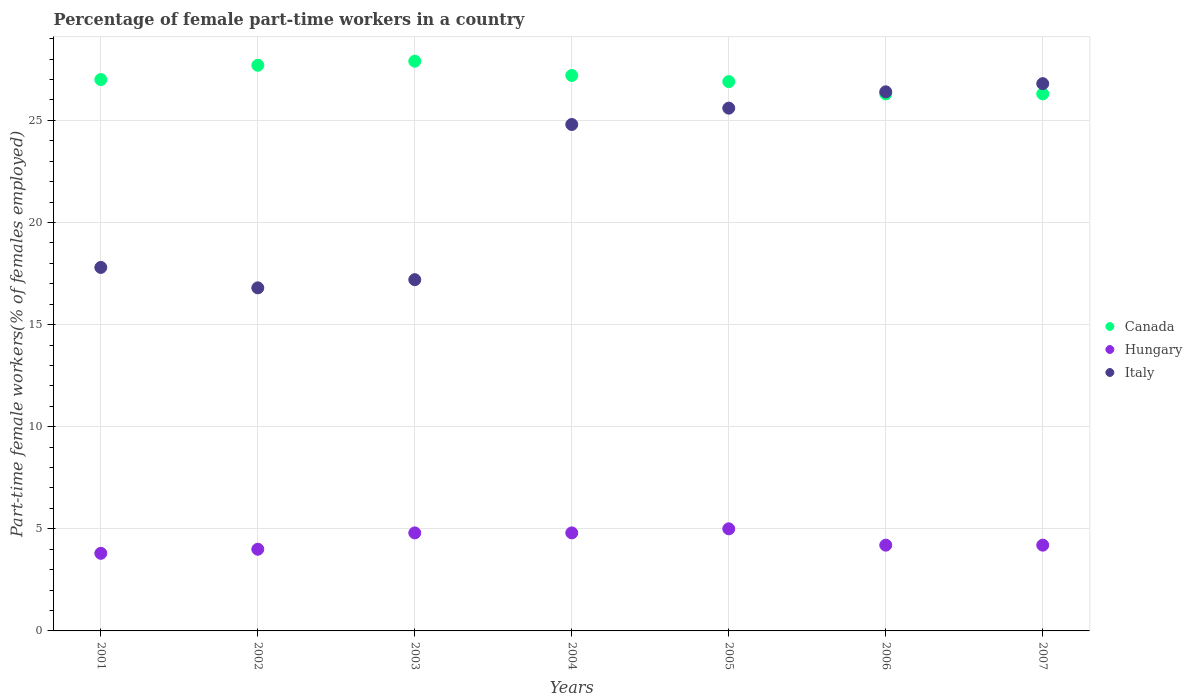Is the number of dotlines equal to the number of legend labels?
Your answer should be very brief. Yes. What is the percentage of female part-time workers in Hungary in 2007?
Ensure brevity in your answer.  4.2. Across all years, what is the minimum percentage of female part-time workers in Canada?
Your response must be concise. 26.3. In which year was the percentage of female part-time workers in Italy maximum?
Offer a very short reply. 2007. In which year was the percentage of female part-time workers in Canada minimum?
Offer a very short reply. 2006. What is the total percentage of female part-time workers in Italy in the graph?
Provide a short and direct response. 155.4. What is the difference between the percentage of female part-time workers in Hungary in 2002 and that in 2007?
Your response must be concise. -0.2. What is the difference between the percentage of female part-time workers in Hungary in 2004 and the percentage of female part-time workers in Italy in 2002?
Give a very brief answer. -12. What is the average percentage of female part-time workers in Hungary per year?
Provide a succinct answer. 4.4. In the year 2002, what is the difference between the percentage of female part-time workers in Hungary and percentage of female part-time workers in Italy?
Offer a terse response. -12.8. In how many years, is the percentage of female part-time workers in Canada greater than 1 %?
Your answer should be very brief. 7. What is the ratio of the percentage of female part-time workers in Canada in 2001 to that in 2007?
Provide a short and direct response. 1.03. What is the difference between the highest and the second highest percentage of female part-time workers in Canada?
Your answer should be compact. 0.2. What is the difference between the highest and the lowest percentage of female part-time workers in Hungary?
Your answer should be compact. 1.2. In how many years, is the percentage of female part-time workers in Hungary greater than the average percentage of female part-time workers in Hungary taken over all years?
Keep it short and to the point. 3. Is the sum of the percentage of female part-time workers in Canada in 2001 and 2002 greater than the maximum percentage of female part-time workers in Italy across all years?
Give a very brief answer. Yes. Is it the case that in every year, the sum of the percentage of female part-time workers in Hungary and percentage of female part-time workers in Canada  is greater than the percentage of female part-time workers in Italy?
Your answer should be very brief. Yes. How many dotlines are there?
Your response must be concise. 3. How many years are there in the graph?
Your answer should be compact. 7. What is the difference between two consecutive major ticks on the Y-axis?
Provide a succinct answer. 5. Does the graph contain any zero values?
Provide a succinct answer. No. Where does the legend appear in the graph?
Give a very brief answer. Center right. What is the title of the graph?
Keep it short and to the point. Percentage of female part-time workers in a country. Does "Greenland" appear as one of the legend labels in the graph?
Give a very brief answer. No. What is the label or title of the X-axis?
Provide a short and direct response. Years. What is the label or title of the Y-axis?
Your response must be concise. Part-time female workers(% of females employed). What is the Part-time female workers(% of females employed) of Hungary in 2001?
Offer a terse response. 3.8. What is the Part-time female workers(% of females employed) in Italy in 2001?
Provide a short and direct response. 17.8. What is the Part-time female workers(% of females employed) of Canada in 2002?
Offer a very short reply. 27.7. What is the Part-time female workers(% of females employed) of Italy in 2002?
Give a very brief answer. 16.8. What is the Part-time female workers(% of females employed) of Canada in 2003?
Your answer should be compact. 27.9. What is the Part-time female workers(% of females employed) of Hungary in 2003?
Make the answer very short. 4.8. What is the Part-time female workers(% of females employed) in Italy in 2003?
Your answer should be compact. 17.2. What is the Part-time female workers(% of females employed) in Canada in 2004?
Give a very brief answer. 27.2. What is the Part-time female workers(% of females employed) of Hungary in 2004?
Your answer should be compact. 4.8. What is the Part-time female workers(% of females employed) in Italy in 2004?
Offer a very short reply. 24.8. What is the Part-time female workers(% of females employed) in Canada in 2005?
Your response must be concise. 26.9. What is the Part-time female workers(% of females employed) of Hungary in 2005?
Offer a very short reply. 5. What is the Part-time female workers(% of females employed) of Italy in 2005?
Your answer should be very brief. 25.6. What is the Part-time female workers(% of females employed) in Canada in 2006?
Your answer should be compact. 26.3. What is the Part-time female workers(% of females employed) in Hungary in 2006?
Provide a succinct answer. 4.2. What is the Part-time female workers(% of females employed) of Italy in 2006?
Provide a succinct answer. 26.4. What is the Part-time female workers(% of females employed) in Canada in 2007?
Provide a succinct answer. 26.3. What is the Part-time female workers(% of females employed) of Hungary in 2007?
Ensure brevity in your answer.  4.2. What is the Part-time female workers(% of females employed) of Italy in 2007?
Your answer should be compact. 26.8. Across all years, what is the maximum Part-time female workers(% of females employed) of Canada?
Ensure brevity in your answer.  27.9. Across all years, what is the maximum Part-time female workers(% of females employed) of Hungary?
Ensure brevity in your answer.  5. Across all years, what is the maximum Part-time female workers(% of females employed) of Italy?
Offer a very short reply. 26.8. Across all years, what is the minimum Part-time female workers(% of females employed) of Canada?
Give a very brief answer. 26.3. Across all years, what is the minimum Part-time female workers(% of females employed) of Hungary?
Offer a very short reply. 3.8. Across all years, what is the minimum Part-time female workers(% of females employed) in Italy?
Provide a succinct answer. 16.8. What is the total Part-time female workers(% of females employed) in Canada in the graph?
Your answer should be very brief. 189.3. What is the total Part-time female workers(% of females employed) in Hungary in the graph?
Offer a very short reply. 30.8. What is the total Part-time female workers(% of females employed) of Italy in the graph?
Make the answer very short. 155.4. What is the difference between the Part-time female workers(% of females employed) in Italy in 2001 and that in 2002?
Your answer should be compact. 1. What is the difference between the Part-time female workers(% of females employed) in Canada in 2001 and that in 2003?
Make the answer very short. -0.9. What is the difference between the Part-time female workers(% of females employed) of Canada in 2001 and that in 2005?
Provide a succinct answer. 0.1. What is the difference between the Part-time female workers(% of females employed) of Hungary in 2001 and that in 2007?
Your response must be concise. -0.4. What is the difference between the Part-time female workers(% of females employed) in Italy in 2001 and that in 2007?
Give a very brief answer. -9. What is the difference between the Part-time female workers(% of females employed) of Hungary in 2002 and that in 2003?
Your answer should be very brief. -0.8. What is the difference between the Part-time female workers(% of females employed) in Hungary in 2002 and that in 2004?
Offer a terse response. -0.8. What is the difference between the Part-time female workers(% of females employed) of Hungary in 2002 and that in 2005?
Keep it short and to the point. -1. What is the difference between the Part-time female workers(% of females employed) of Hungary in 2002 and that in 2006?
Give a very brief answer. -0.2. What is the difference between the Part-time female workers(% of females employed) of Hungary in 2002 and that in 2007?
Offer a very short reply. -0.2. What is the difference between the Part-time female workers(% of females employed) in Italy in 2002 and that in 2007?
Make the answer very short. -10. What is the difference between the Part-time female workers(% of females employed) in Canada in 2003 and that in 2004?
Ensure brevity in your answer.  0.7. What is the difference between the Part-time female workers(% of females employed) of Canada in 2003 and that in 2005?
Offer a terse response. 1. What is the difference between the Part-time female workers(% of females employed) in Hungary in 2003 and that in 2005?
Provide a short and direct response. -0.2. What is the difference between the Part-time female workers(% of females employed) in Italy in 2003 and that in 2005?
Ensure brevity in your answer.  -8.4. What is the difference between the Part-time female workers(% of females employed) of Hungary in 2003 and that in 2006?
Keep it short and to the point. 0.6. What is the difference between the Part-time female workers(% of females employed) of Italy in 2003 and that in 2006?
Keep it short and to the point. -9.2. What is the difference between the Part-time female workers(% of females employed) in Hungary in 2003 and that in 2007?
Keep it short and to the point. 0.6. What is the difference between the Part-time female workers(% of females employed) in Italy in 2003 and that in 2007?
Your response must be concise. -9.6. What is the difference between the Part-time female workers(% of females employed) of Italy in 2004 and that in 2005?
Ensure brevity in your answer.  -0.8. What is the difference between the Part-time female workers(% of females employed) in Hungary in 2004 and that in 2006?
Ensure brevity in your answer.  0.6. What is the difference between the Part-time female workers(% of females employed) of Italy in 2004 and that in 2006?
Ensure brevity in your answer.  -1.6. What is the difference between the Part-time female workers(% of females employed) in Canada in 2004 and that in 2007?
Your answer should be very brief. 0.9. What is the difference between the Part-time female workers(% of females employed) in Hungary in 2004 and that in 2007?
Keep it short and to the point. 0.6. What is the difference between the Part-time female workers(% of females employed) in Canada in 2005 and that in 2006?
Provide a succinct answer. 0.6. What is the difference between the Part-time female workers(% of females employed) in Canada in 2005 and that in 2007?
Make the answer very short. 0.6. What is the difference between the Part-time female workers(% of females employed) in Hungary in 2005 and that in 2007?
Make the answer very short. 0.8. What is the difference between the Part-time female workers(% of females employed) of Italy in 2005 and that in 2007?
Provide a succinct answer. -1.2. What is the difference between the Part-time female workers(% of females employed) in Hungary in 2006 and that in 2007?
Give a very brief answer. 0. What is the difference between the Part-time female workers(% of females employed) of Italy in 2006 and that in 2007?
Your answer should be compact. -0.4. What is the difference between the Part-time female workers(% of females employed) of Hungary in 2001 and the Part-time female workers(% of females employed) of Italy in 2002?
Give a very brief answer. -13. What is the difference between the Part-time female workers(% of females employed) in Canada in 2001 and the Part-time female workers(% of females employed) in Italy in 2003?
Make the answer very short. 9.8. What is the difference between the Part-time female workers(% of females employed) in Canada in 2001 and the Part-time female workers(% of females employed) in Hungary in 2004?
Your response must be concise. 22.2. What is the difference between the Part-time female workers(% of females employed) of Hungary in 2001 and the Part-time female workers(% of females employed) of Italy in 2004?
Offer a very short reply. -21. What is the difference between the Part-time female workers(% of females employed) in Canada in 2001 and the Part-time female workers(% of females employed) in Italy in 2005?
Offer a very short reply. 1.4. What is the difference between the Part-time female workers(% of females employed) in Hungary in 2001 and the Part-time female workers(% of females employed) in Italy in 2005?
Offer a very short reply. -21.8. What is the difference between the Part-time female workers(% of females employed) in Canada in 2001 and the Part-time female workers(% of females employed) in Hungary in 2006?
Your answer should be very brief. 22.8. What is the difference between the Part-time female workers(% of females employed) of Hungary in 2001 and the Part-time female workers(% of females employed) of Italy in 2006?
Your answer should be compact. -22.6. What is the difference between the Part-time female workers(% of females employed) in Canada in 2001 and the Part-time female workers(% of females employed) in Hungary in 2007?
Your answer should be very brief. 22.8. What is the difference between the Part-time female workers(% of females employed) of Hungary in 2001 and the Part-time female workers(% of females employed) of Italy in 2007?
Provide a short and direct response. -23. What is the difference between the Part-time female workers(% of females employed) in Canada in 2002 and the Part-time female workers(% of females employed) in Hungary in 2003?
Provide a short and direct response. 22.9. What is the difference between the Part-time female workers(% of females employed) of Canada in 2002 and the Part-time female workers(% of females employed) of Hungary in 2004?
Offer a terse response. 22.9. What is the difference between the Part-time female workers(% of females employed) in Canada in 2002 and the Part-time female workers(% of females employed) in Italy in 2004?
Offer a terse response. 2.9. What is the difference between the Part-time female workers(% of females employed) of Hungary in 2002 and the Part-time female workers(% of females employed) of Italy in 2004?
Offer a terse response. -20.8. What is the difference between the Part-time female workers(% of females employed) of Canada in 2002 and the Part-time female workers(% of females employed) of Hungary in 2005?
Give a very brief answer. 22.7. What is the difference between the Part-time female workers(% of females employed) in Hungary in 2002 and the Part-time female workers(% of females employed) in Italy in 2005?
Provide a short and direct response. -21.6. What is the difference between the Part-time female workers(% of females employed) of Canada in 2002 and the Part-time female workers(% of females employed) of Hungary in 2006?
Your answer should be very brief. 23.5. What is the difference between the Part-time female workers(% of females employed) of Canada in 2002 and the Part-time female workers(% of females employed) of Italy in 2006?
Keep it short and to the point. 1.3. What is the difference between the Part-time female workers(% of females employed) of Hungary in 2002 and the Part-time female workers(% of females employed) of Italy in 2006?
Keep it short and to the point. -22.4. What is the difference between the Part-time female workers(% of females employed) of Hungary in 2002 and the Part-time female workers(% of females employed) of Italy in 2007?
Offer a very short reply. -22.8. What is the difference between the Part-time female workers(% of females employed) in Canada in 2003 and the Part-time female workers(% of females employed) in Hungary in 2004?
Make the answer very short. 23.1. What is the difference between the Part-time female workers(% of females employed) of Hungary in 2003 and the Part-time female workers(% of females employed) of Italy in 2004?
Give a very brief answer. -20. What is the difference between the Part-time female workers(% of females employed) of Canada in 2003 and the Part-time female workers(% of females employed) of Hungary in 2005?
Offer a terse response. 22.9. What is the difference between the Part-time female workers(% of females employed) of Hungary in 2003 and the Part-time female workers(% of females employed) of Italy in 2005?
Give a very brief answer. -20.8. What is the difference between the Part-time female workers(% of females employed) of Canada in 2003 and the Part-time female workers(% of females employed) of Hungary in 2006?
Make the answer very short. 23.7. What is the difference between the Part-time female workers(% of females employed) of Hungary in 2003 and the Part-time female workers(% of females employed) of Italy in 2006?
Give a very brief answer. -21.6. What is the difference between the Part-time female workers(% of females employed) in Canada in 2003 and the Part-time female workers(% of females employed) in Hungary in 2007?
Give a very brief answer. 23.7. What is the difference between the Part-time female workers(% of females employed) of Hungary in 2003 and the Part-time female workers(% of females employed) of Italy in 2007?
Keep it short and to the point. -22. What is the difference between the Part-time female workers(% of females employed) of Canada in 2004 and the Part-time female workers(% of females employed) of Italy in 2005?
Provide a short and direct response. 1.6. What is the difference between the Part-time female workers(% of females employed) in Hungary in 2004 and the Part-time female workers(% of females employed) in Italy in 2005?
Your answer should be very brief. -20.8. What is the difference between the Part-time female workers(% of females employed) in Canada in 2004 and the Part-time female workers(% of females employed) in Hungary in 2006?
Your answer should be very brief. 23. What is the difference between the Part-time female workers(% of females employed) in Canada in 2004 and the Part-time female workers(% of females employed) in Italy in 2006?
Your answer should be very brief. 0.8. What is the difference between the Part-time female workers(% of females employed) in Hungary in 2004 and the Part-time female workers(% of females employed) in Italy in 2006?
Offer a very short reply. -21.6. What is the difference between the Part-time female workers(% of females employed) of Canada in 2004 and the Part-time female workers(% of females employed) of Hungary in 2007?
Your response must be concise. 23. What is the difference between the Part-time female workers(% of females employed) in Canada in 2005 and the Part-time female workers(% of females employed) in Hungary in 2006?
Your answer should be very brief. 22.7. What is the difference between the Part-time female workers(% of females employed) in Canada in 2005 and the Part-time female workers(% of females employed) in Italy in 2006?
Offer a very short reply. 0.5. What is the difference between the Part-time female workers(% of females employed) in Hungary in 2005 and the Part-time female workers(% of females employed) in Italy in 2006?
Your response must be concise. -21.4. What is the difference between the Part-time female workers(% of females employed) in Canada in 2005 and the Part-time female workers(% of females employed) in Hungary in 2007?
Your answer should be very brief. 22.7. What is the difference between the Part-time female workers(% of females employed) of Hungary in 2005 and the Part-time female workers(% of females employed) of Italy in 2007?
Keep it short and to the point. -21.8. What is the difference between the Part-time female workers(% of females employed) of Canada in 2006 and the Part-time female workers(% of females employed) of Hungary in 2007?
Ensure brevity in your answer.  22.1. What is the difference between the Part-time female workers(% of females employed) of Hungary in 2006 and the Part-time female workers(% of females employed) of Italy in 2007?
Your answer should be compact. -22.6. What is the average Part-time female workers(% of females employed) in Canada per year?
Make the answer very short. 27.04. What is the average Part-time female workers(% of females employed) in Hungary per year?
Make the answer very short. 4.4. What is the average Part-time female workers(% of females employed) of Italy per year?
Your answer should be compact. 22.2. In the year 2001, what is the difference between the Part-time female workers(% of females employed) in Canada and Part-time female workers(% of females employed) in Hungary?
Keep it short and to the point. 23.2. In the year 2002, what is the difference between the Part-time female workers(% of females employed) in Canada and Part-time female workers(% of females employed) in Hungary?
Ensure brevity in your answer.  23.7. In the year 2002, what is the difference between the Part-time female workers(% of females employed) of Canada and Part-time female workers(% of females employed) of Italy?
Offer a terse response. 10.9. In the year 2002, what is the difference between the Part-time female workers(% of females employed) in Hungary and Part-time female workers(% of females employed) in Italy?
Provide a succinct answer. -12.8. In the year 2003, what is the difference between the Part-time female workers(% of females employed) of Canada and Part-time female workers(% of females employed) of Hungary?
Provide a short and direct response. 23.1. In the year 2004, what is the difference between the Part-time female workers(% of females employed) of Canada and Part-time female workers(% of females employed) of Hungary?
Your answer should be very brief. 22.4. In the year 2004, what is the difference between the Part-time female workers(% of females employed) of Hungary and Part-time female workers(% of females employed) of Italy?
Offer a terse response. -20. In the year 2005, what is the difference between the Part-time female workers(% of females employed) in Canada and Part-time female workers(% of females employed) in Hungary?
Offer a very short reply. 21.9. In the year 2005, what is the difference between the Part-time female workers(% of females employed) in Hungary and Part-time female workers(% of females employed) in Italy?
Your response must be concise. -20.6. In the year 2006, what is the difference between the Part-time female workers(% of females employed) in Canada and Part-time female workers(% of females employed) in Hungary?
Offer a very short reply. 22.1. In the year 2006, what is the difference between the Part-time female workers(% of females employed) of Hungary and Part-time female workers(% of females employed) of Italy?
Keep it short and to the point. -22.2. In the year 2007, what is the difference between the Part-time female workers(% of females employed) of Canada and Part-time female workers(% of females employed) of Hungary?
Offer a terse response. 22.1. In the year 2007, what is the difference between the Part-time female workers(% of females employed) of Canada and Part-time female workers(% of females employed) of Italy?
Provide a short and direct response. -0.5. In the year 2007, what is the difference between the Part-time female workers(% of females employed) in Hungary and Part-time female workers(% of females employed) in Italy?
Offer a terse response. -22.6. What is the ratio of the Part-time female workers(% of females employed) in Canada in 2001 to that in 2002?
Provide a short and direct response. 0.97. What is the ratio of the Part-time female workers(% of females employed) of Hungary in 2001 to that in 2002?
Make the answer very short. 0.95. What is the ratio of the Part-time female workers(% of females employed) in Italy in 2001 to that in 2002?
Your answer should be compact. 1.06. What is the ratio of the Part-time female workers(% of females employed) in Hungary in 2001 to that in 2003?
Your answer should be compact. 0.79. What is the ratio of the Part-time female workers(% of females employed) of Italy in 2001 to that in 2003?
Keep it short and to the point. 1.03. What is the ratio of the Part-time female workers(% of females employed) of Canada in 2001 to that in 2004?
Offer a terse response. 0.99. What is the ratio of the Part-time female workers(% of females employed) in Hungary in 2001 to that in 2004?
Make the answer very short. 0.79. What is the ratio of the Part-time female workers(% of females employed) in Italy in 2001 to that in 2004?
Your answer should be compact. 0.72. What is the ratio of the Part-time female workers(% of females employed) in Hungary in 2001 to that in 2005?
Your response must be concise. 0.76. What is the ratio of the Part-time female workers(% of females employed) in Italy in 2001 to that in 2005?
Provide a succinct answer. 0.7. What is the ratio of the Part-time female workers(% of females employed) in Canada in 2001 to that in 2006?
Keep it short and to the point. 1.03. What is the ratio of the Part-time female workers(% of females employed) of Hungary in 2001 to that in 2006?
Provide a short and direct response. 0.9. What is the ratio of the Part-time female workers(% of females employed) in Italy in 2001 to that in 2006?
Offer a terse response. 0.67. What is the ratio of the Part-time female workers(% of females employed) of Canada in 2001 to that in 2007?
Provide a succinct answer. 1.03. What is the ratio of the Part-time female workers(% of females employed) of Hungary in 2001 to that in 2007?
Make the answer very short. 0.9. What is the ratio of the Part-time female workers(% of females employed) in Italy in 2001 to that in 2007?
Give a very brief answer. 0.66. What is the ratio of the Part-time female workers(% of females employed) of Italy in 2002 to that in 2003?
Your answer should be compact. 0.98. What is the ratio of the Part-time female workers(% of females employed) of Canada in 2002 to that in 2004?
Provide a succinct answer. 1.02. What is the ratio of the Part-time female workers(% of females employed) in Hungary in 2002 to that in 2004?
Your response must be concise. 0.83. What is the ratio of the Part-time female workers(% of females employed) of Italy in 2002 to that in 2004?
Offer a terse response. 0.68. What is the ratio of the Part-time female workers(% of females employed) in Canada in 2002 to that in 2005?
Give a very brief answer. 1.03. What is the ratio of the Part-time female workers(% of females employed) of Hungary in 2002 to that in 2005?
Your answer should be compact. 0.8. What is the ratio of the Part-time female workers(% of females employed) of Italy in 2002 to that in 2005?
Your response must be concise. 0.66. What is the ratio of the Part-time female workers(% of females employed) of Canada in 2002 to that in 2006?
Give a very brief answer. 1.05. What is the ratio of the Part-time female workers(% of females employed) in Hungary in 2002 to that in 2006?
Provide a short and direct response. 0.95. What is the ratio of the Part-time female workers(% of females employed) in Italy in 2002 to that in 2006?
Give a very brief answer. 0.64. What is the ratio of the Part-time female workers(% of females employed) of Canada in 2002 to that in 2007?
Your answer should be very brief. 1.05. What is the ratio of the Part-time female workers(% of females employed) of Hungary in 2002 to that in 2007?
Your answer should be very brief. 0.95. What is the ratio of the Part-time female workers(% of females employed) in Italy in 2002 to that in 2007?
Provide a short and direct response. 0.63. What is the ratio of the Part-time female workers(% of females employed) in Canada in 2003 to that in 2004?
Keep it short and to the point. 1.03. What is the ratio of the Part-time female workers(% of females employed) in Italy in 2003 to that in 2004?
Offer a very short reply. 0.69. What is the ratio of the Part-time female workers(% of females employed) of Canada in 2003 to that in 2005?
Provide a succinct answer. 1.04. What is the ratio of the Part-time female workers(% of females employed) of Hungary in 2003 to that in 2005?
Keep it short and to the point. 0.96. What is the ratio of the Part-time female workers(% of females employed) in Italy in 2003 to that in 2005?
Offer a terse response. 0.67. What is the ratio of the Part-time female workers(% of females employed) in Canada in 2003 to that in 2006?
Make the answer very short. 1.06. What is the ratio of the Part-time female workers(% of females employed) in Hungary in 2003 to that in 2006?
Give a very brief answer. 1.14. What is the ratio of the Part-time female workers(% of females employed) of Italy in 2003 to that in 2006?
Your answer should be compact. 0.65. What is the ratio of the Part-time female workers(% of females employed) in Canada in 2003 to that in 2007?
Your answer should be very brief. 1.06. What is the ratio of the Part-time female workers(% of females employed) of Hungary in 2003 to that in 2007?
Your answer should be very brief. 1.14. What is the ratio of the Part-time female workers(% of females employed) in Italy in 2003 to that in 2007?
Your answer should be very brief. 0.64. What is the ratio of the Part-time female workers(% of females employed) of Canada in 2004 to that in 2005?
Offer a terse response. 1.01. What is the ratio of the Part-time female workers(% of females employed) in Hungary in 2004 to that in 2005?
Ensure brevity in your answer.  0.96. What is the ratio of the Part-time female workers(% of females employed) of Italy in 2004 to that in 2005?
Give a very brief answer. 0.97. What is the ratio of the Part-time female workers(% of females employed) in Canada in 2004 to that in 2006?
Offer a terse response. 1.03. What is the ratio of the Part-time female workers(% of females employed) of Italy in 2004 to that in 2006?
Give a very brief answer. 0.94. What is the ratio of the Part-time female workers(% of females employed) of Canada in 2004 to that in 2007?
Offer a terse response. 1.03. What is the ratio of the Part-time female workers(% of females employed) in Italy in 2004 to that in 2007?
Keep it short and to the point. 0.93. What is the ratio of the Part-time female workers(% of females employed) of Canada in 2005 to that in 2006?
Offer a very short reply. 1.02. What is the ratio of the Part-time female workers(% of females employed) in Hungary in 2005 to that in 2006?
Your answer should be compact. 1.19. What is the ratio of the Part-time female workers(% of females employed) of Italy in 2005 to that in 2006?
Your answer should be compact. 0.97. What is the ratio of the Part-time female workers(% of females employed) of Canada in 2005 to that in 2007?
Give a very brief answer. 1.02. What is the ratio of the Part-time female workers(% of females employed) of Hungary in 2005 to that in 2007?
Provide a succinct answer. 1.19. What is the ratio of the Part-time female workers(% of females employed) in Italy in 2005 to that in 2007?
Your response must be concise. 0.96. What is the ratio of the Part-time female workers(% of females employed) of Hungary in 2006 to that in 2007?
Ensure brevity in your answer.  1. What is the ratio of the Part-time female workers(% of females employed) in Italy in 2006 to that in 2007?
Offer a very short reply. 0.99. What is the difference between the highest and the second highest Part-time female workers(% of females employed) of Italy?
Offer a terse response. 0.4. What is the difference between the highest and the lowest Part-time female workers(% of females employed) in Canada?
Offer a terse response. 1.6. 